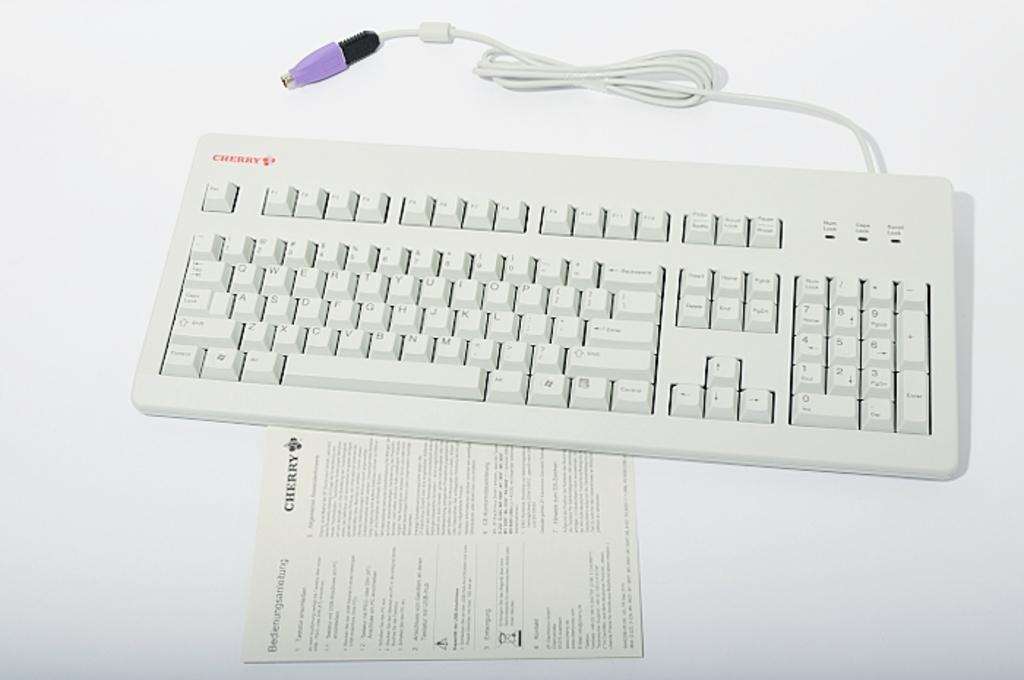<image>
Provide a brief description of the given image. A white keyboard with a purple plug and its corresponding instruction manual. 